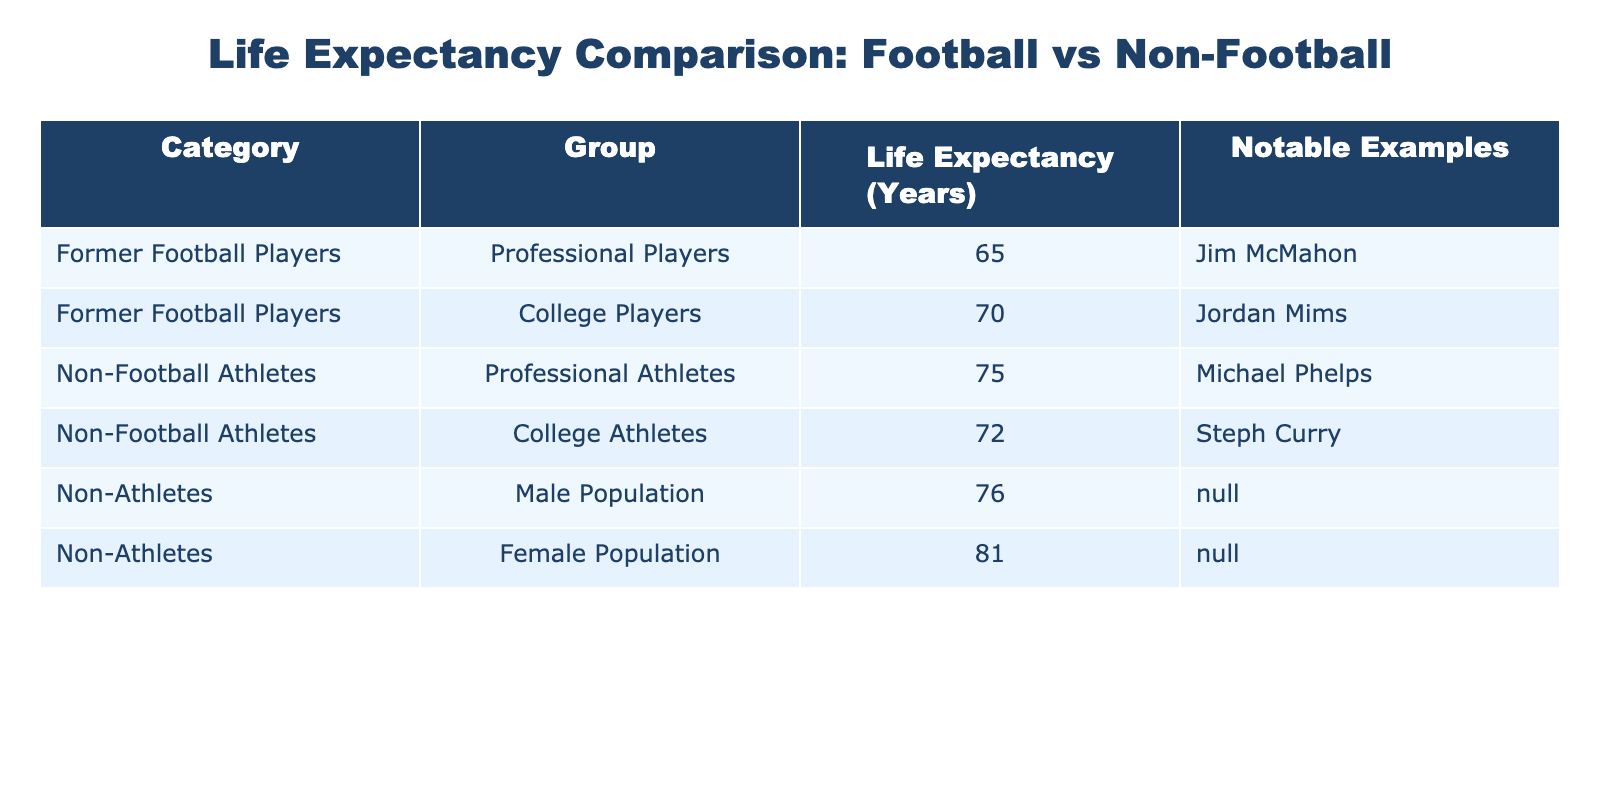What is the life expectancy of professional football players? The table indicates that the life expectancy of professional football players is 65 years. This is clearly stated in the data under the "Life Expectancy (Years)" column for the "Professional Players" group within "Former Football Players."
Answer: 65 years What notable example is given for college football players? According to the table, the notable example for college football players is Jordan Mims. This information is provided in the "Notable Examples" column for the "College Players" row under "Former Football Players."
Answer: Jordan Mims What is the average life expectancy of all non-athletes listed in the table? The life expectancy for male non-athletes is 76 years, and for female non-athletes, it is 81 years. To find the average, add these two values (76 + 81 = 157) and divide by 2, resulting in an average of 157 / 2 = 78.5 years.
Answer: 78.5 years Is the life expectancy of professional athletes higher than that of college football players? The life expectancy of professional athletes is 75 years, while college football players have a life expectancy of 70 years. Since 75 years is greater than 70 years, the statement is true.
Answer: Yes How many more years do non-football professional athletes live compared to former professional football players? Non-football professional athletes have a life expectancy of 75 years, while former professional football players live 65 years. To find the difference, subtract 65 from 75, resulting in 75 - 65 = 10 years.
Answer: 10 years What is the difference in life expectancy between non-athletes and college athletes? The life expectancy for non-athletes (average of male and female) is 78.5 years, while college athletes have a life expectancy of 72 years. To find the difference, subtract 72 from 78.5, resulting in 78.5 - 72 = 6.5 years.
Answer: 6.5 years Is it true that college athletes have a higher life expectancy than former college football players? The life expectancy of college athletes is 72 years, while that of former college football players is 70 years. Since 72 years is greater than 70 years, the statement is true.
Answer: Yes What is the least life expectancy recorded in the table? The least life expectancy is for professional football players, which is recorded as 65 years. By comparing all entries in the "Life Expectancy (Years)" column, this is the lowest value listed.
Answer: 65 years 